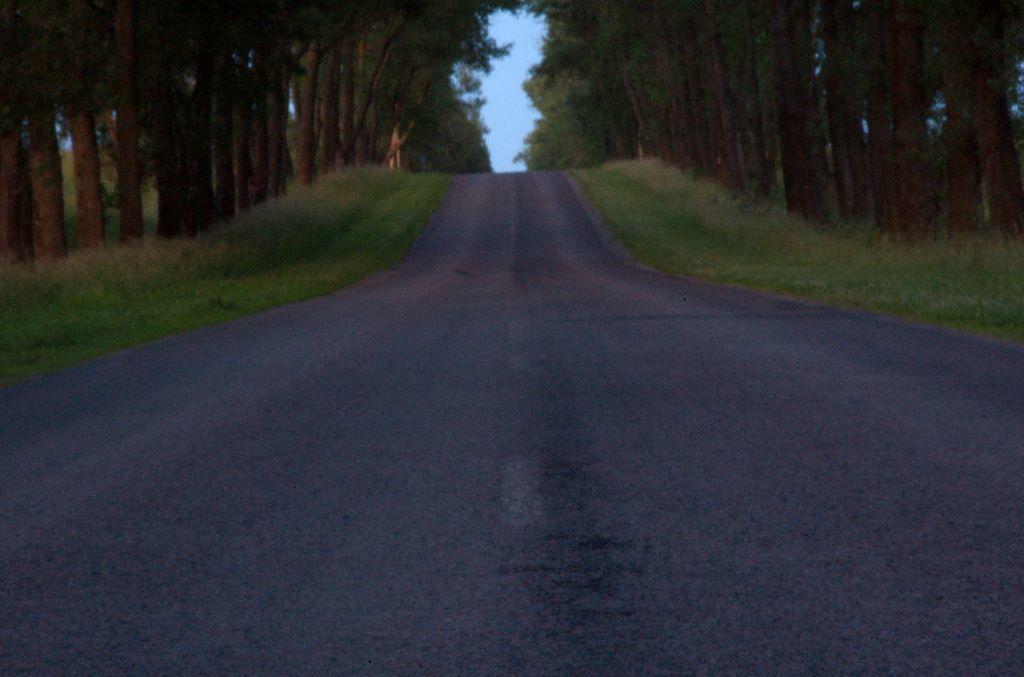Describe this image in one or two sentences. In this image we can see a road, shrubs, grass, trees and sky. 